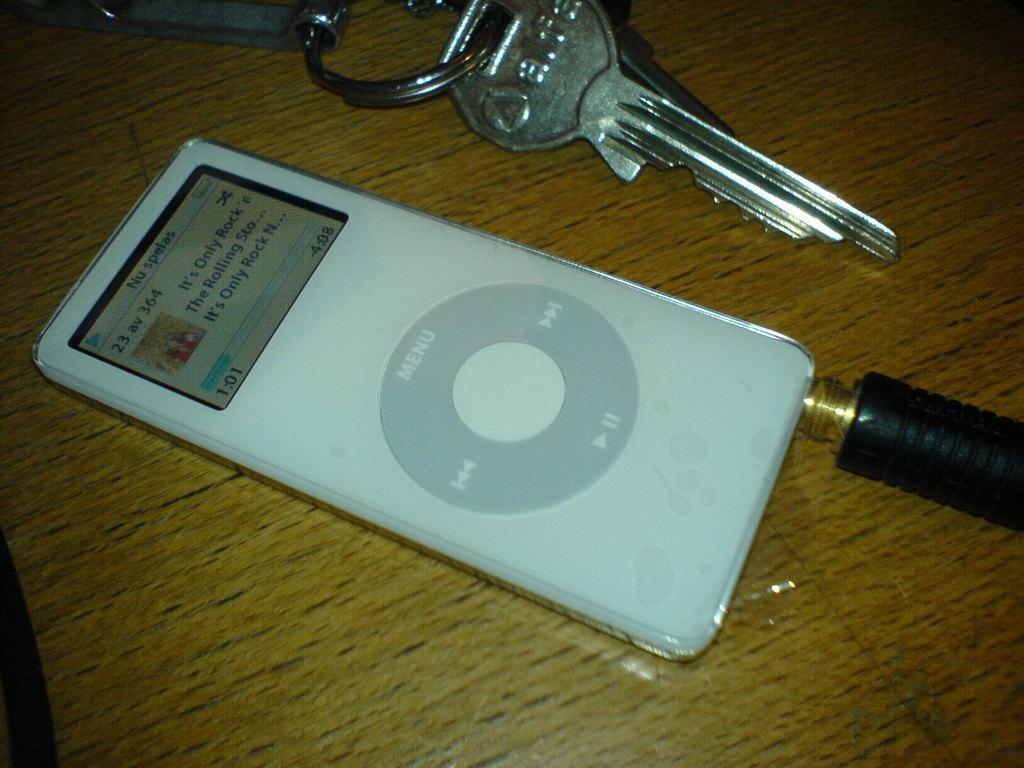Can you describe this image briefly? In this image we can see a device with a screen placed on the table. At the top of the image we can see some keys. 